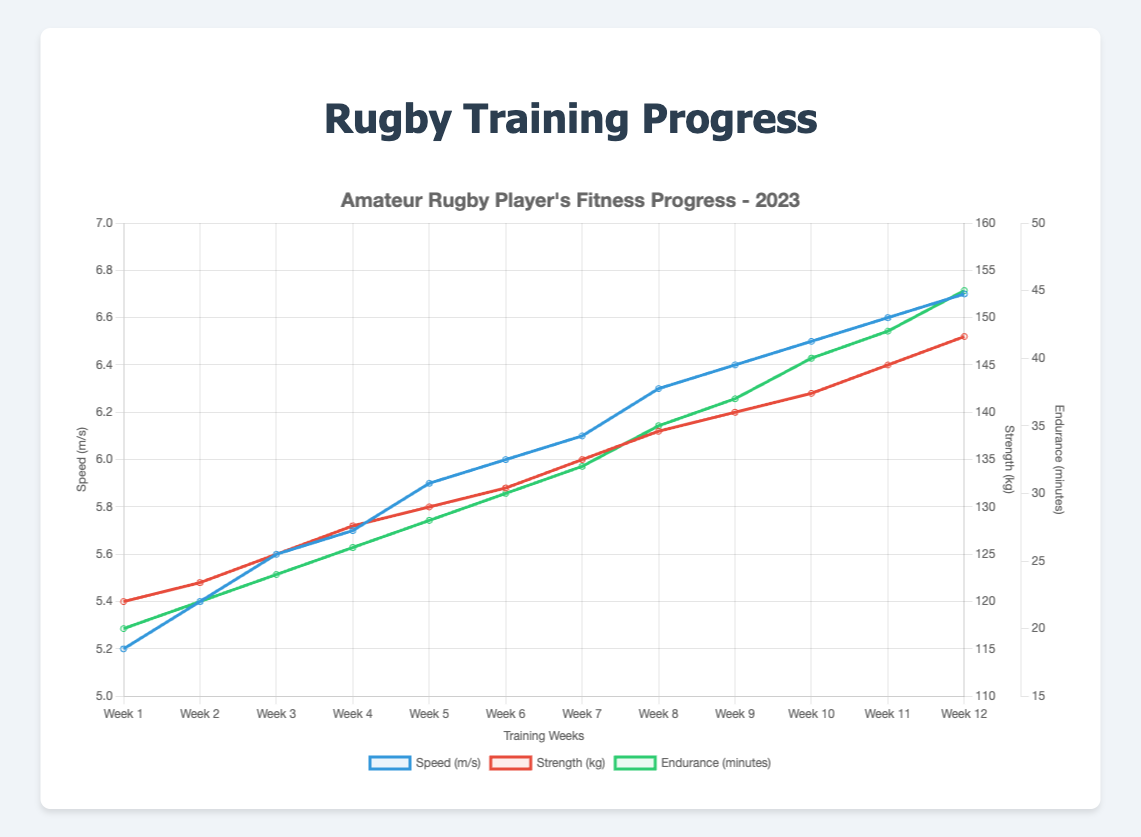What is the speed (m/s) in week 5? Locate the point corresponding to week 5 on the speed (blue) line. The y-axis indicates a value of 5.9 m/s.
Answer: 5.9 How does the strength (kg) in week 3 compare to week 7? Locate the points for strength (red) in week 3 and week 7. Week 3 has 125 kg, and week 7 has 135 kg. Therefore, strength increased from week 3 to week 7.
Answer: Week 7 is greater What is the average endurance (minutes) over the first four weeks? The endurance values for the first four weeks are 20, 22, 24, and 26 minutes. Sum them up: 20 + 22 + 24 + 26 = 92. Divide by 4 to find the average: 92 / 4 = 23 minutes.
Answer: 23 Which week shows the highest speed (m/s)? Identify the highest point on the speed (blue) line. Week 12 has the highest speed value at 6.7 m/s.
Answer: Week 12 What is the total increase in strength (kg) from week 1 to week 12? Strength in week 1 is 120 kg, and in week 12, it is 148 kg. The increase is 148 - 120 = 28 kg.
Answer: 28 Does endurance (minutes) increase every week? Examine the endurance (green) line. It shows a consistently increasing trend without any decreases each week.
Answer: Yes By how much did speed (m/s) increase from week 6 to week 10? Speed in week 6 is 6.0 m/s, and in week 10, it is 6.5 m/s. The increase is 6.5 - 6.0 = 0.5 m/s.
Answer: 0.5 What is the slope of the speed (m/s) line between week 1 and week 2? The slope is calculated by the change in speed over the change in time. Speed increased from 5.2 m/s to 5.4 m/s, and the time increased from week 1 to week 2. Slope = (5.4 - 5.2) / (2 - 1) = 0.2 m/s/week.
Answer: 0.2 How does the increment in endurance (minutes) between week 8 and week 9 compare to that between week 4 and week 5? Week 8 endurance is 35 minutes and week 9 is 37 minutes, an increase of 2 minutes. Week 4 is 26 minutes and week 5 is 28 minutes, again an increase of 2 minutes. The increments are equal.
Answer: Equal By what percentage did strength (kg) increase from week 1 to week 12? Initial strength is 120 kg, and final strength is 148 kg. The increase is 148 - 120 = 28 kg. Percentage increase = (28 / 120) * 100 = 23.33%.
Answer: 23.33% 